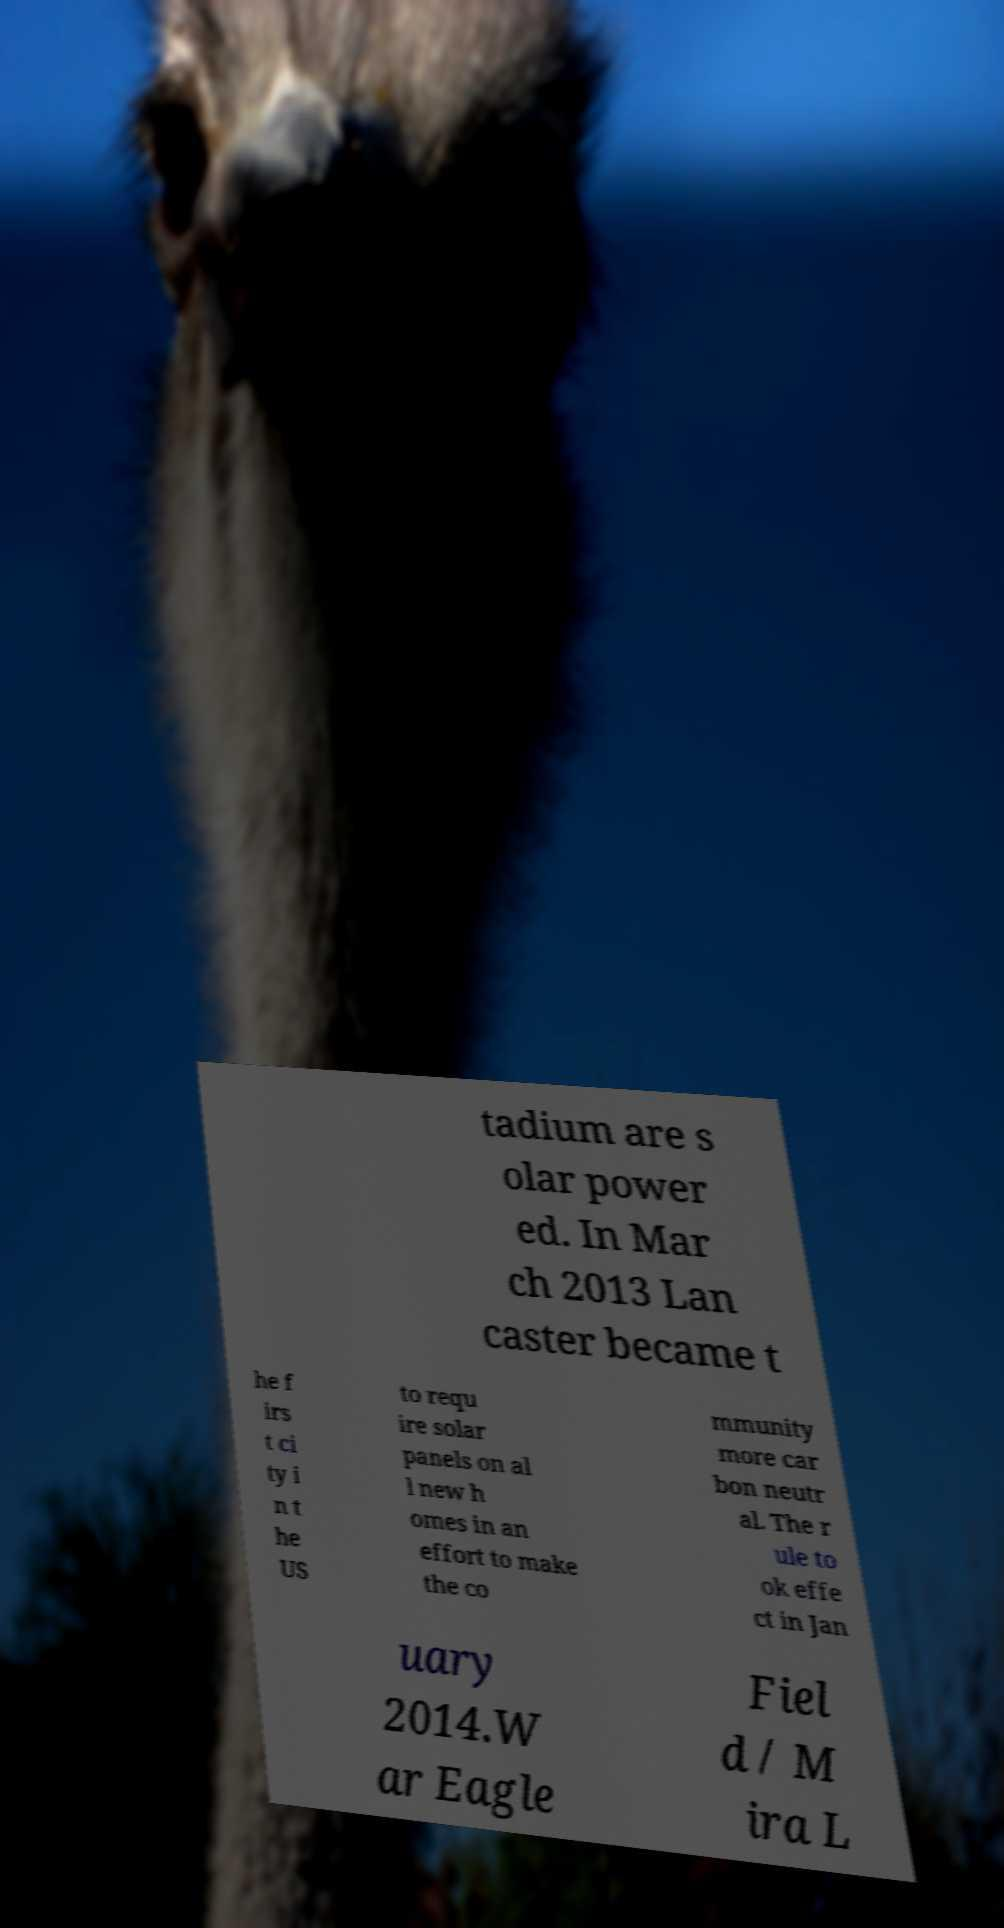I need the written content from this picture converted into text. Can you do that? tadium are s olar power ed. In Mar ch 2013 Lan caster became t he f irs t ci ty i n t he US to requ ire solar panels on al l new h omes in an effort to make the co mmunity more car bon neutr al. The r ule to ok effe ct in Jan uary 2014.W ar Eagle Fiel d / M ira L 